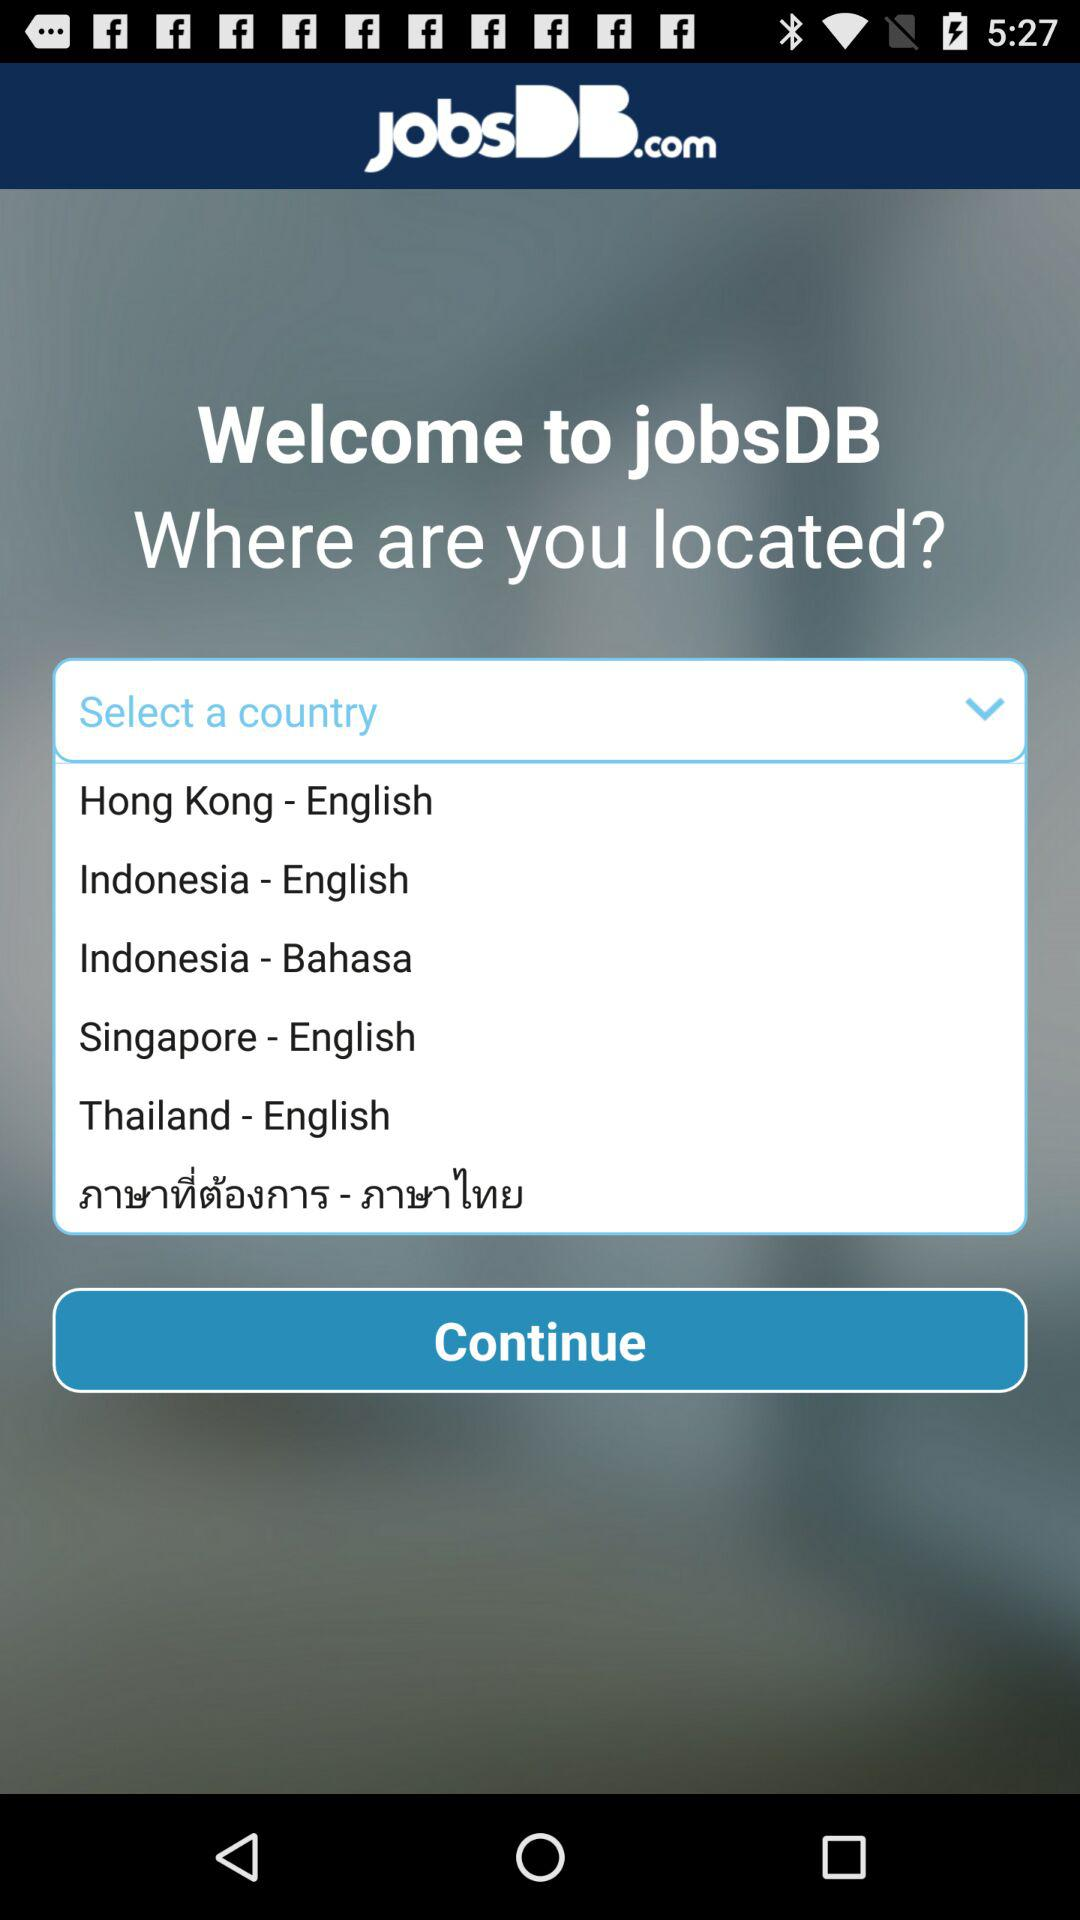How many countries are available for selection?
Answer the question using a single word or phrase. 6 